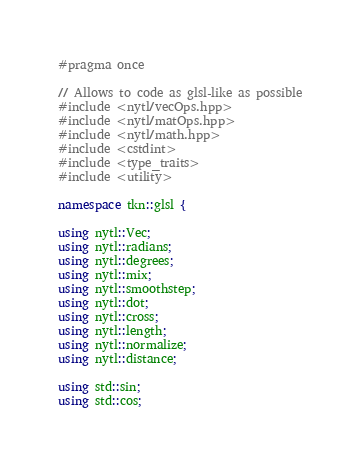<code> <loc_0><loc_0><loc_500><loc_500><_C++_>#pragma once

// Allows to code as glsl-like as possible
#include <nytl/vecOps.hpp>
#include <nytl/matOps.hpp>
#include <nytl/math.hpp>
#include <cstdint>
#include <type_traits>
#include <utility>

namespace tkn::glsl {

using nytl::Vec;
using nytl::radians;
using nytl::degrees;
using nytl::mix;
using nytl::smoothstep;
using nytl::dot;
using nytl::cross;
using nytl::length;
using nytl::normalize;
using nytl::distance;

using std::sin;
using std::cos;</code> 